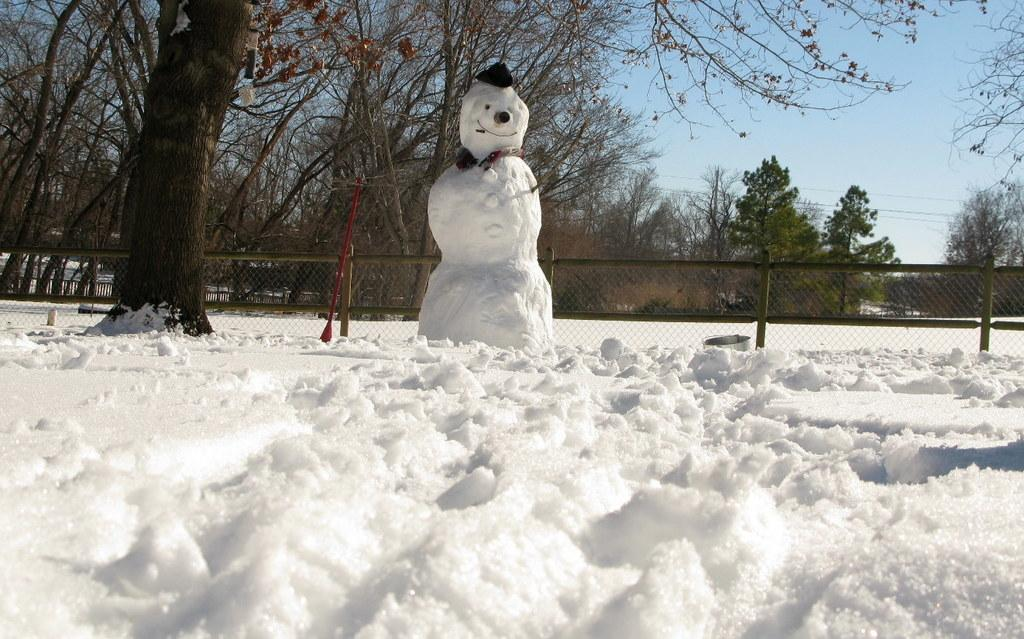What is the main subject in the middle of the image? There is a snowman in the middle of the image. What is covering the ground in the image? There is snow on the ground. What type of structure can be seen in the image? There is a fence in the image. What type of vegetation is visible in the image? There are trees visible in the image. What is visible at the top of the image? The sky is visible at the top of the image. What type of oatmeal is being used to decorate the snowman in the image? There is no oatmeal present in the image; the snowman is made of snow and decorated with other materials. 